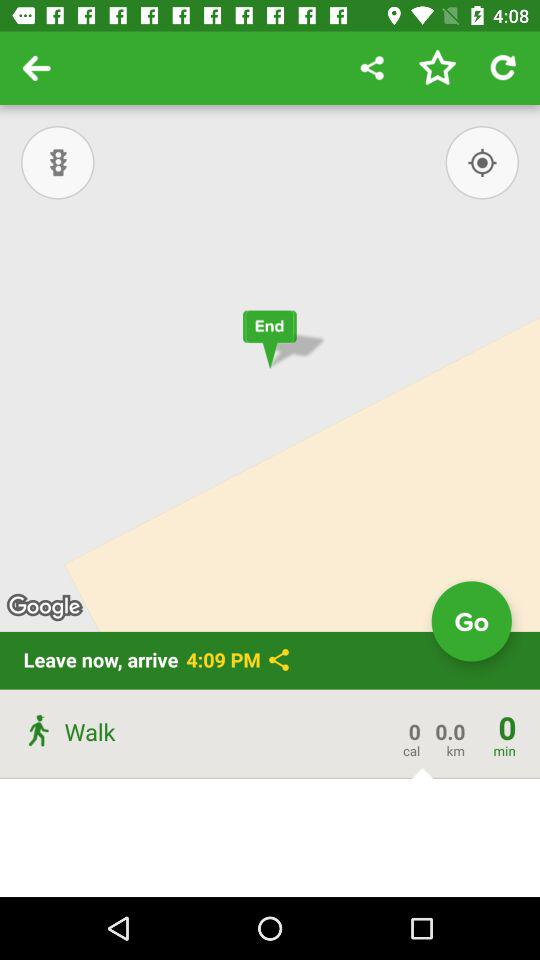What is the number of calories? The number of calories is 0. 